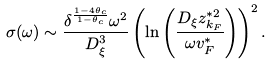<formula> <loc_0><loc_0><loc_500><loc_500>\sigma ( \omega ) \sim \frac { \delta ^ { \frac { 1 - 4 \theta _ { c } } { 1 - \theta _ { c } } } \omega ^ { 2 } } { D _ { \xi } ^ { 3 } } \left ( \ln \left ( \frac { D _ { \xi } z _ { k _ { F } } ^ { * 2 } } { \omega v _ { F } ^ { * } } \right ) \right ) ^ { 2 } .</formula> 